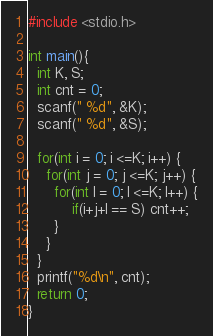<code> <loc_0><loc_0><loc_500><loc_500><_C_>#include <stdio.h>

int main(){
  int K, S;
  int cnt = 0;
  scanf(" %d", &K);
  scanf(" %d", &S);
  
  for(int i = 0; i <=K; i++) {
    for(int j = 0; j <=K; j++) {
      for(int l = 0; l <=K; l++) {
          if(i+j+l == S) cnt++;
      }
    }
  }
  printf("%d\n", cnt);
  return 0;
}</code> 